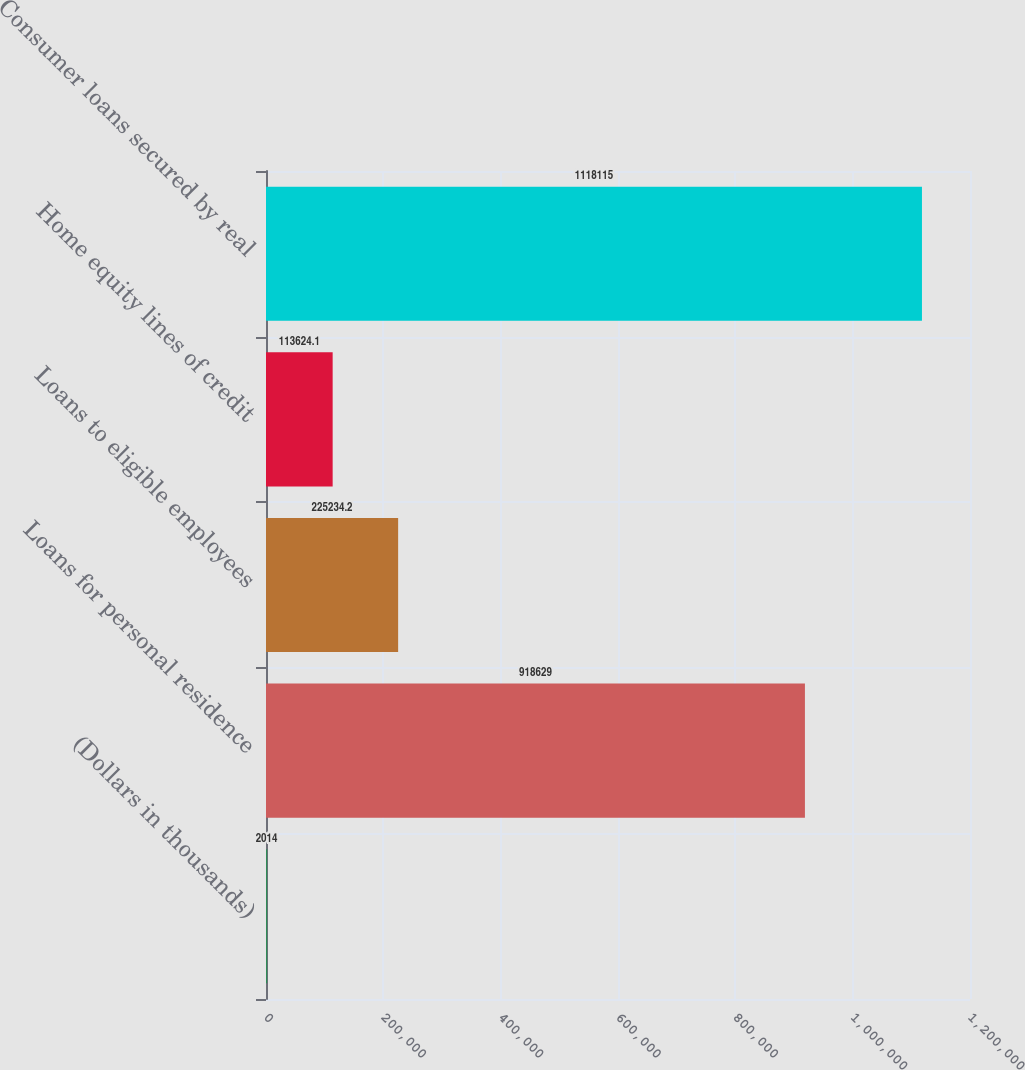Convert chart to OTSL. <chart><loc_0><loc_0><loc_500><loc_500><bar_chart><fcel>(Dollars in thousands)<fcel>Loans for personal residence<fcel>Loans to eligible employees<fcel>Home equity lines of credit<fcel>Consumer loans secured by real<nl><fcel>2014<fcel>918629<fcel>225234<fcel>113624<fcel>1.11812e+06<nl></chart> 